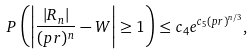<formula> <loc_0><loc_0><loc_500><loc_500>P \left ( \left | \frac { | R _ { n } | } { ( p r ) ^ { n } } - W \right | \geq 1 \right ) \leq c _ { 4 } e ^ { c _ { 5 } ( p r ) ^ { n / 3 } } ,</formula> 